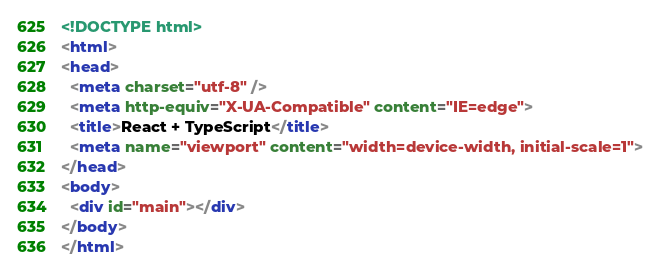Convert code to text. <code><loc_0><loc_0><loc_500><loc_500><_HTML_><!DOCTYPE html>
<html>
<head>
  <meta charset="utf-8" />
  <meta http-equiv="X-UA-Compatible" content="IE=edge">
  <title>React + TypeScript</title>
  <meta name="viewport" content="width=device-width, initial-scale=1">
</head>
<body>
  <div id="main"></div>
</body>
</html></code> 